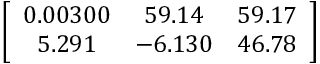Convert formula to latex. <formula><loc_0><loc_0><loc_500><loc_500>\left [ { \begin{array} { c c c } { 0 . 0 0 3 0 0 } & { 5 9 . 1 4 } & { 5 9 . 1 7 } \\ { 5 . 2 9 1 } & { - 6 . 1 3 0 } & { 4 6 . 7 8 } \end{array} } \right ]</formula> 